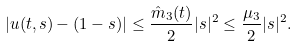<formula> <loc_0><loc_0><loc_500><loc_500>| u ( t , s ) - ( 1 - s ) | \leq \frac { \hat { m } _ { 3 } ( t ) } { 2 } | s | ^ { 2 } \leq \frac { \mu _ { 3 } } { 2 } | s | ^ { 2 } .</formula> 